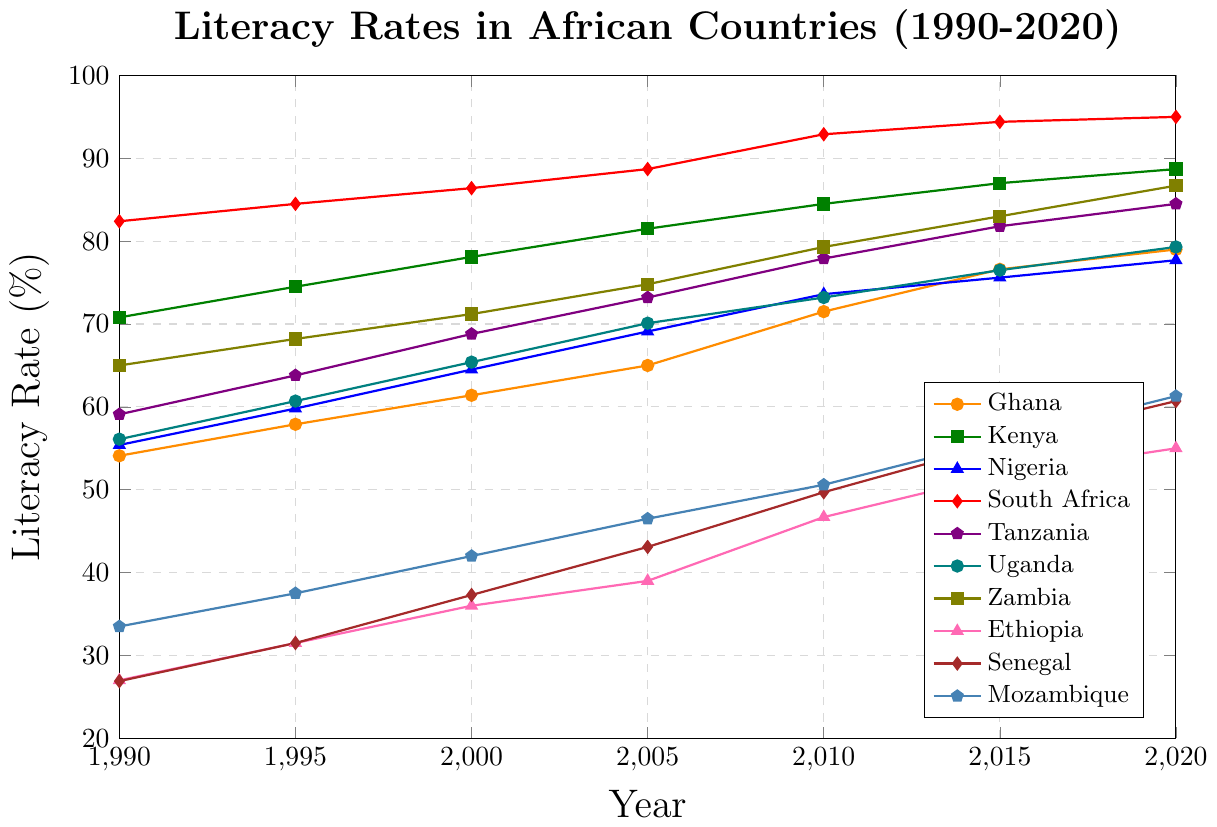What is the literacy rate of Ghana in 2000? Locate the line for Ghana (orange) and find the value at the 2000 mark on the x-axis.
Answer: 61.4 Which country has the highest literacy rate in 2020? Compare the endpoints of all lines (2020) and find the highest value. South Africa has the highest endpoint.
Answer: South Africa What is the difference in literacy rate between Uganda and Ethiopia in 2010? Find the points for Uganda and Ethiopia in 2010, subtract the literacy rate of Ethiopia from Uganda's rate. Uganda in 2010 is 73.2, Ethiopia is 46.7. So, 73.2 - 46.7 = 26.5.
Answer: 26.5 How did Kenya's literacy rate change from 1990 to 2020? Find the literacy rate for Kenya in 1990 and in 2020, then calculate the difference. Kenya in 1990 is 70.8, and in 2020 is 88.7. So, 88.7 - 70.8 = 17.9.
Answer: 17.9 Between 1995 and 2005, which country showed the greatest increase in literacy rate? For each country, subtract the 1995 literacy rate from the 2005 literacy rate and identify the maximum value. Upon comparison, Senegal has the greatest increase (43.1 - 31.5 = 11.6).
Answer: Senegal What is the average literacy rate for Mozambique across all years provided? Compute the sum of literacy rates for Mozambique across all years, then divide by the number of years. (33.5 + 37.5 + 42.0 + 46.5 + 50.6 + 56.0 + 61.3) / 7 = 46.2.
Answer: 46.2 Which country has the lowest literacy rate in 1990, and what is the rate? Locate the literacy rates for all countries in 1990 and identify the lowest value. Ethiopia has the lowest rate in 1990 at 27.0.
Answer: Ethiopia, 27.0 What's the median literacy rate of Uganda from 1990 to 2020? List the literacy rates for Uganda: 56.1, 60.7, 65.4, 70.1, 73.2, 76.5, 79.3. The median is the middle value, so ordered, the median value is 70.1.
Answer: 70.1 Which country had a literacy rate closest to 80% in 2015? Look at the 2015 values for all countries and find which one is closest to 80%. The closest value is Zambia with 83.0.
Answer: Zambia 